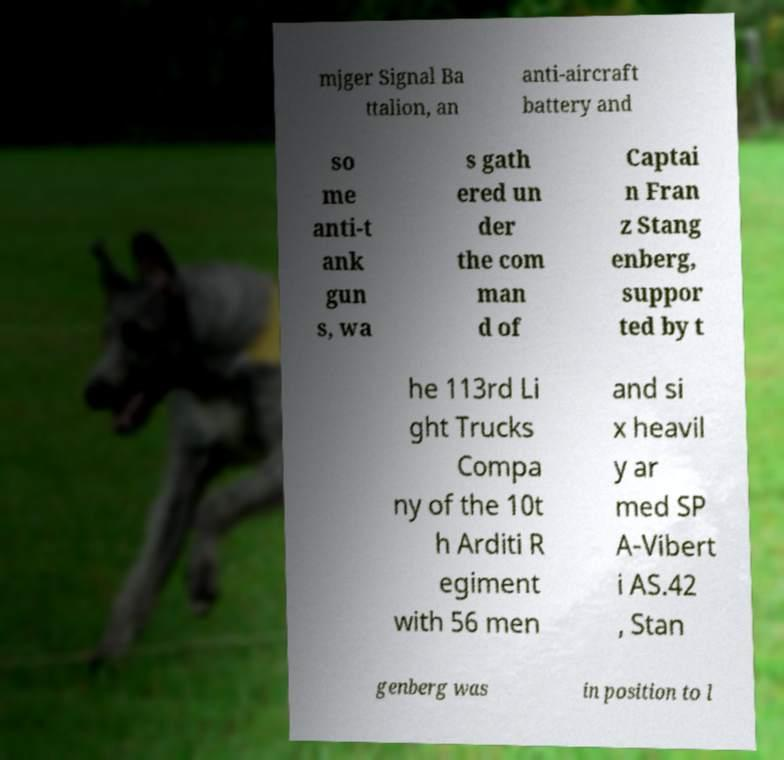Please identify and transcribe the text found in this image. mjger Signal Ba ttalion, an anti-aircraft battery and so me anti-t ank gun s, wa s gath ered un der the com man d of Captai n Fran z Stang enberg, suppor ted by t he 113rd Li ght Trucks Compa ny of the 10t h Arditi R egiment with 56 men and si x heavil y ar med SP A-Vibert i AS.42 , Stan genberg was in position to l 